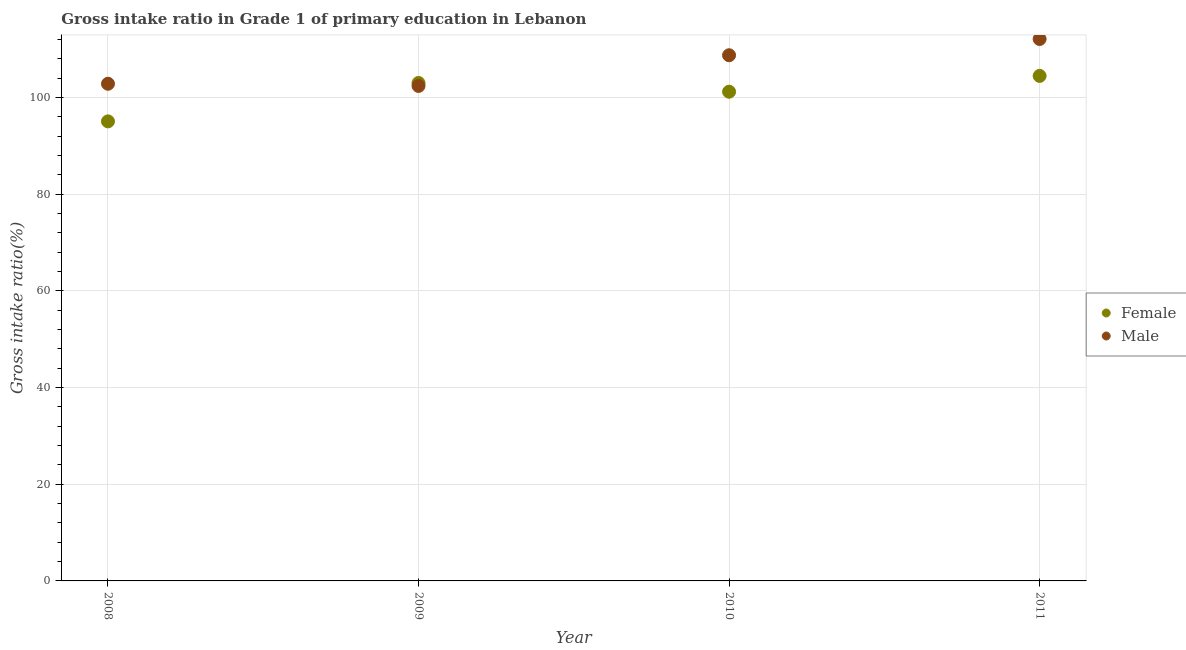Is the number of dotlines equal to the number of legend labels?
Make the answer very short. Yes. What is the gross intake ratio(female) in 2011?
Provide a succinct answer. 104.49. Across all years, what is the maximum gross intake ratio(male)?
Give a very brief answer. 112.13. Across all years, what is the minimum gross intake ratio(male)?
Your response must be concise. 102.42. In which year was the gross intake ratio(male) maximum?
Your answer should be very brief. 2011. What is the total gross intake ratio(male) in the graph?
Your response must be concise. 426.18. What is the difference between the gross intake ratio(female) in 2009 and that in 2011?
Make the answer very short. -1.46. What is the difference between the gross intake ratio(female) in 2011 and the gross intake ratio(male) in 2010?
Your answer should be very brief. -4.27. What is the average gross intake ratio(male) per year?
Offer a very short reply. 106.54. In the year 2010, what is the difference between the gross intake ratio(female) and gross intake ratio(male)?
Provide a succinct answer. -7.54. What is the ratio of the gross intake ratio(male) in 2008 to that in 2010?
Provide a succinct answer. 0.95. Is the difference between the gross intake ratio(female) in 2009 and 2011 greater than the difference between the gross intake ratio(male) in 2009 and 2011?
Offer a terse response. Yes. What is the difference between the highest and the second highest gross intake ratio(male)?
Offer a very short reply. 3.36. What is the difference between the highest and the lowest gross intake ratio(female)?
Your answer should be very brief. 9.41. In how many years, is the gross intake ratio(male) greater than the average gross intake ratio(male) taken over all years?
Offer a terse response. 2. Does the gross intake ratio(female) monotonically increase over the years?
Provide a succinct answer. No. How many dotlines are there?
Ensure brevity in your answer.  2. Are the values on the major ticks of Y-axis written in scientific E-notation?
Make the answer very short. No. Does the graph contain grids?
Provide a short and direct response. Yes. How many legend labels are there?
Ensure brevity in your answer.  2. What is the title of the graph?
Your answer should be very brief. Gross intake ratio in Grade 1 of primary education in Lebanon. What is the label or title of the X-axis?
Provide a succinct answer. Year. What is the label or title of the Y-axis?
Your response must be concise. Gross intake ratio(%). What is the Gross intake ratio(%) in Female in 2008?
Ensure brevity in your answer.  95.08. What is the Gross intake ratio(%) in Male in 2008?
Your answer should be compact. 102.87. What is the Gross intake ratio(%) of Female in 2009?
Provide a succinct answer. 103.03. What is the Gross intake ratio(%) of Male in 2009?
Give a very brief answer. 102.42. What is the Gross intake ratio(%) of Female in 2010?
Keep it short and to the point. 101.22. What is the Gross intake ratio(%) of Male in 2010?
Offer a very short reply. 108.76. What is the Gross intake ratio(%) of Female in 2011?
Keep it short and to the point. 104.49. What is the Gross intake ratio(%) of Male in 2011?
Provide a short and direct response. 112.13. Across all years, what is the maximum Gross intake ratio(%) in Female?
Give a very brief answer. 104.49. Across all years, what is the maximum Gross intake ratio(%) in Male?
Provide a succinct answer. 112.13. Across all years, what is the minimum Gross intake ratio(%) in Female?
Provide a short and direct response. 95.08. Across all years, what is the minimum Gross intake ratio(%) in Male?
Your answer should be compact. 102.42. What is the total Gross intake ratio(%) in Female in the graph?
Your response must be concise. 403.82. What is the total Gross intake ratio(%) of Male in the graph?
Keep it short and to the point. 426.18. What is the difference between the Gross intake ratio(%) in Female in 2008 and that in 2009?
Your answer should be very brief. -7.95. What is the difference between the Gross intake ratio(%) of Male in 2008 and that in 2009?
Provide a short and direct response. 0.45. What is the difference between the Gross intake ratio(%) in Female in 2008 and that in 2010?
Make the answer very short. -6.14. What is the difference between the Gross intake ratio(%) of Male in 2008 and that in 2010?
Your response must be concise. -5.9. What is the difference between the Gross intake ratio(%) of Female in 2008 and that in 2011?
Your answer should be compact. -9.41. What is the difference between the Gross intake ratio(%) of Male in 2008 and that in 2011?
Your answer should be compact. -9.26. What is the difference between the Gross intake ratio(%) in Female in 2009 and that in 2010?
Ensure brevity in your answer.  1.81. What is the difference between the Gross intake ratio(%) in Male in 2009 and that in 2010?
Keep it short and to the point. -6.35. What is the difference between the Gross intake ratio(%) of Female in 2009 and that in 2011?
Ensure brevity in your answer.  -1.46. What is the difference between the Gross intake ratio(%) in Male in 2009 and that in 2011?
Your answer should be very brief. -9.71. What is the difference between the Gross intake ratio(%) of Female in 2010 and that in 2011?
Your answer should be very brief. -3.27. What is the difference between the Gross intake ratio(%) in Male in 2010 and that in 2011?
Make the answer very short. -3.36. What is the difference between the Gross intake ratio(%) of Female in 2008 and the Gross intake ratio(%) of Male in 2009?
Make the answer very short. -7.33. What is the difference between the Gross intake ratio(%) of Female in 2008 and the Gross intake ratio(%) of Male in 2010?
Your response must be concise. -13.68. What is the difference between the Gross intake ratio(%) in Female in 2008 and the Gross intake ratio(%) in Male in 2011?
Provide a short and direct response. -17.05. What is the difference between the Gross intake ratio(%) of Female in 2009 and the Gross intake ratio(%) of Male in 2010?
Keep it short and to the point. -5.73. What is the difference between the Gross intake ratio(%) of Female in 2009 and the Gross intake ratio(%) of Male in 2011?
Your response must be concise. -9.1. What is the difference between the Gross intake ratio(%) of Female in 2010 and the Gross intake ratio(%) of Male in 2011?
Your answer should be very brief. -10.91. What is the average Gross intake ratio(%) of Female per year?
Your response must be concise. 100.96. What is the average Gross intake ratio(%) in Male per year?
Keep it short and to the point. 106.54. In the year 2008, what is the difference between the Gross intake ratio(%) in Female and Gross intake ratio(%) in Male?
Offer a very short reply. -7.78. In the year 2009, what is the difference between the Gross intake ratio(%) of Female and Gross intake ratio(%) of Male?
Ensure brevity in your answer.  0.62. In the year 2010, what is the difference between the Gross intake ratio(%) in Female and Gross intake ratio(%) in Male?
Your answer should be very brief. -7.54. In the year 2011, what is the difference between the Gross intake ratio(%) in Female and Gross intake ratio(%) in Male?
Your response must be concise. -7.64. What is the ratio of the Gross intake ratio(%) in Female in 2008 to that in 2009?
Make the answer very short. 0.92. What is the ratio of the Gross intake ratio(%) in Female in 2008 to that in 2010?
Give a very brief answer. 0.94. What is the ratio of the Gross intake ratio(%) in Male in 2008 to that in 2010?
Give a very brief answer. 0.95. What is the ratio of the Gross intake ratio(%) of Female in 2008 to that in 2011?
Provide a short and direct response. 0.91. What is the ratio of the Gross intake ratio(%) in Male in 2008 to that in 2011?
Provide a short and direct response. 0.92. What is the ratio of the Gross intake ratio(%) of Female in 2009 to that in 2010?
Offer a very short reply. 1.02. What is the ratio of the Gross intake ratio(%) of Male in 2009 to that in 2010?
Provide a short and direct response. 0.94. What is the ratio of the Gross intake ratio(%) of Male in 2009 to that in 2011?
Ensure brevity in your answer.  0.91. What is the ratio of the Gross intake ratio(%) of Female in 2010 to that in 2011?
Keep it short and to the point. 0.97. What is the difference between the highest and the second highest Gross intake ratio(%) in Female?
Provide a succinct answer. 1.46. What is the difference between the highest and the second highest Gross intake ratio(%) in Male?
Provide a succinct answer. 3.36. What is the difference between the highest and the lowest Gross intake ratio(%) of Female?
Make the answer very short. 9.41. What is the difference between the highest and the lowest Gross intake ratio(%) of Male?
Keep it short and to the point. 9.71. 